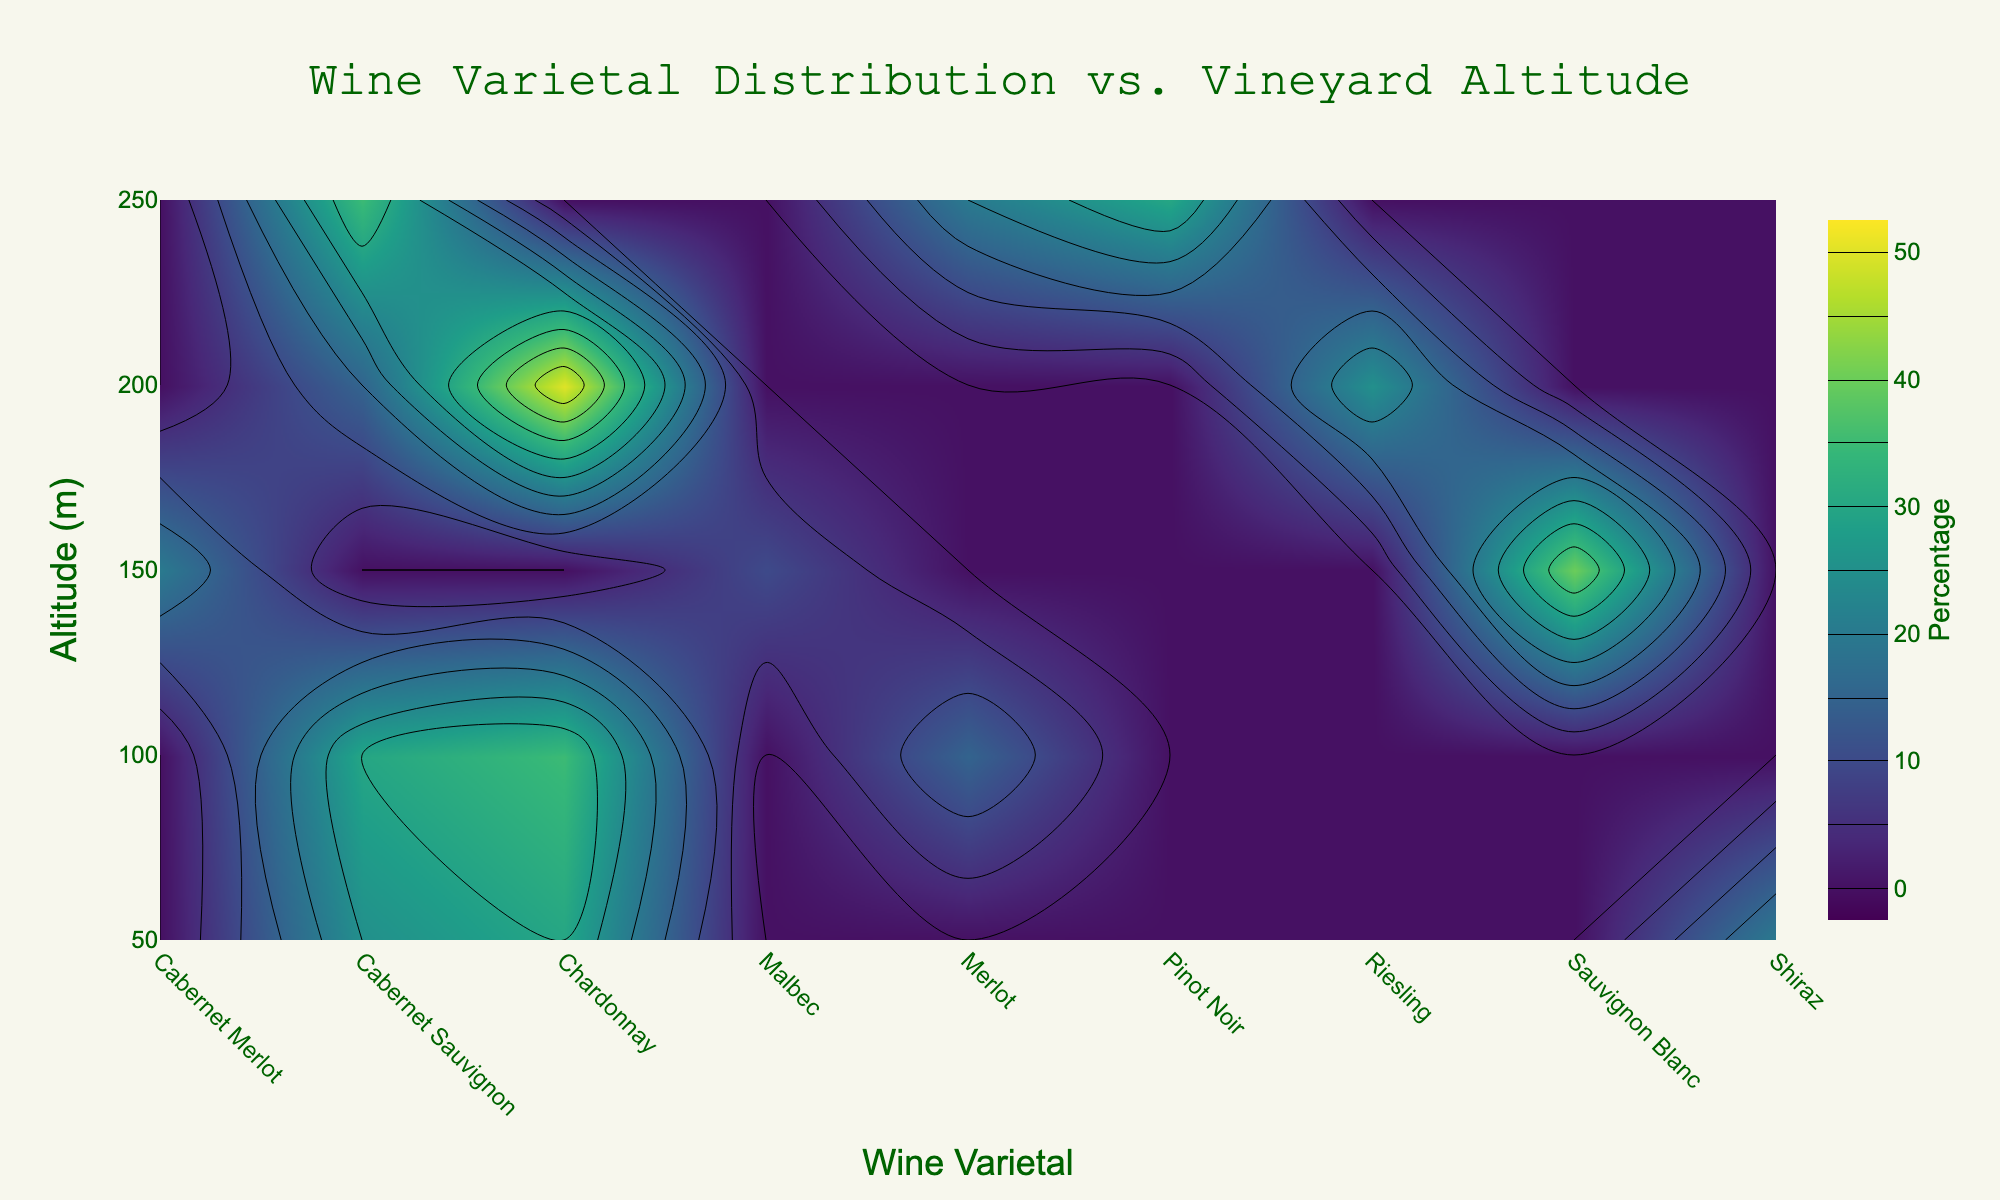What is the title of the plot? The title of the plot is centered at the top of the figure and can be read directly.
Answer: Wine Varietal Distribution vs. Vineyard Altitude What is the altitude range presented on the y-axis? The y-axis represents the vineyard altitude, and the numeric values range from 50 m to 250 m.
Answer: 50 m to 250 m Which vineyard has the highest percentage of Chardonnay? You need to look at the contour plot and identify where the Chardonnay contour line reaches the highest altitude. The highest percentage of Chardonnay is at Leeuwin Estate at 200 m altitude.
Answer: Leeuwin Estate What is the color scale used in the contour plot? The color scale is visible in the color bar next to the contour plot. It ranges from dark colors to bright colors, representing varying percentages. The color scheme used is Viridis.
Answer: Viridis At which altitude do we see the highest percentage of Sauvignon Blanc? Find the contour line associated with Sauvignon Blanc. The highest intensity (darkest color) appears at 150 m.
Answer: 150 m Compare the distribution of Cabernet Sauvignon at 100 m and 250 m. Look for the contour lines at 100 m and 250 m altitudes. At 100 m, Vasse Felix has a certain percentage of Cabernet Sauvignon, and at 250 m, Moss Wood has a different percentage. At 100 m, it is around 30%, and at 250 m, it is around 35%.
Answer: 30% at 100 m, 35% at 250 m What is the percentage of the least common varietal at 50 m? Identify the percentages provided for varietals at 50 m. Shiraz has the lowest percentage, which is 20%.
Answer: 20% Which varietal has the broadest distribution across altitudes? Observe the contour lines and see which varietal appears over a wider altitude range. Chardonnay appears across 50 m to 200 m.
Answer: Chardonnay Is there any varietal that appears in only one vineyard? Check the data along the altitude marks and identify if any varietals are exclusively at one vineyard. Malbec, which appears only at Cullen Wines (150 m), is an example.
Answer: Malbec What is the average percentage of all varietals at 150 m altitude? Sum up all percentages at 150 m altitude and divide by the number of varietals: (40 + 20 + 10) / 3 = 70 / 3 ≈ 23.33%.
Answer: 23.33% 